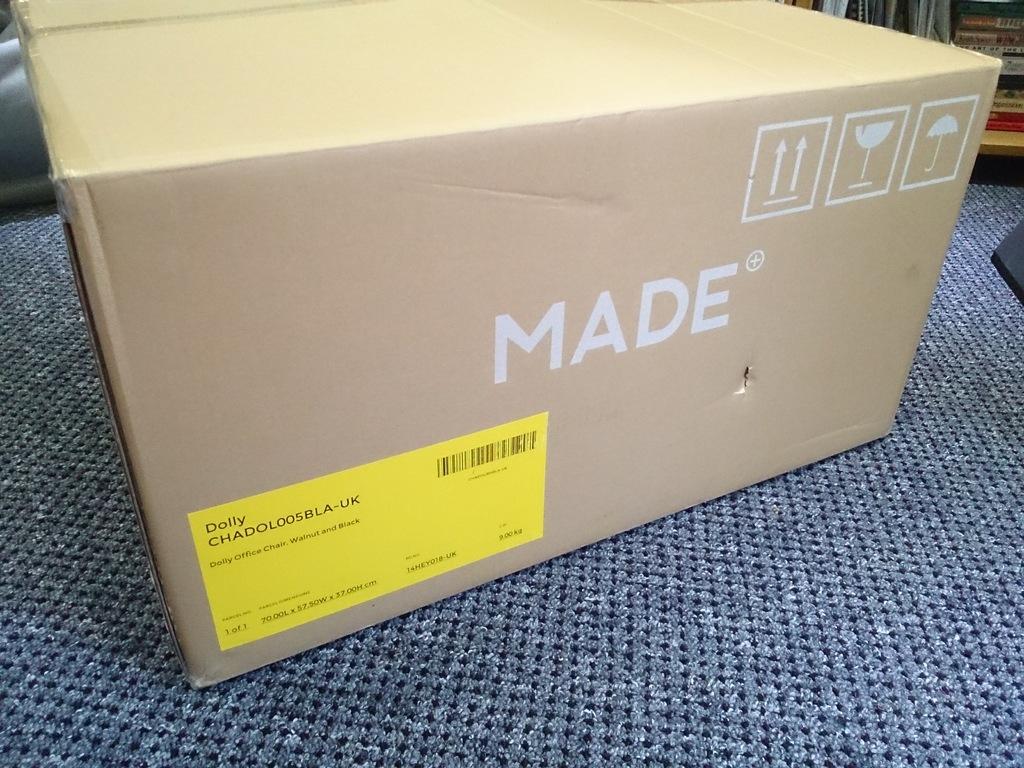What is the big word on the side of the box?
Your response must be concise. Made. What is on the top of the yellow sticker?
Make the answer very short. Dolly. 